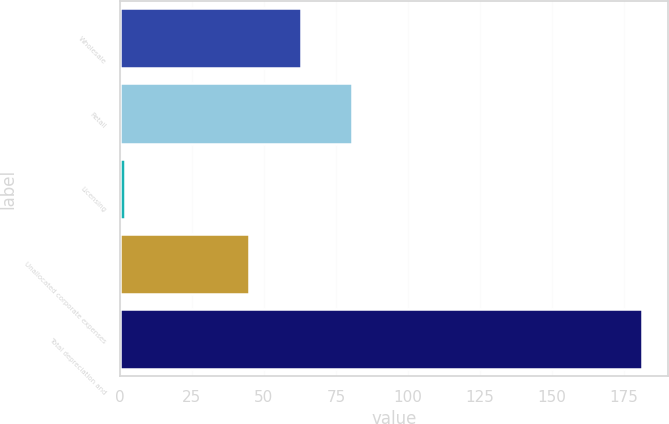Convert chart. <chart><loc_0><loc_0><loc_500><loc_500><bar_chart><fcel>Wholesale<fcel>Retail<fcel>Licensing<fcel>Unallocated corporate expenses<fcel>Total depreciation and<nl><fcel>62.75<fcel>80.7<fcel>1.7<fcel>44.8<fcel>181.2<nl></chart> 